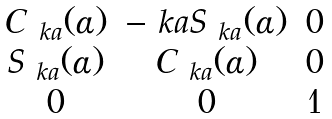<formula> <loc_0><loc_0><loc_500><loc_500>\begin{matrix} C _ { \ k a } ( \alpha ) & - \ k a S _ { \ k a } ( \alpha ) & 0 \\ S _ { \ k a } ( \alpha ) & C _ { \ k a } ( \alpha ) & 0 \\ 0 & 0 & 1 \end{matrix}</formula> 